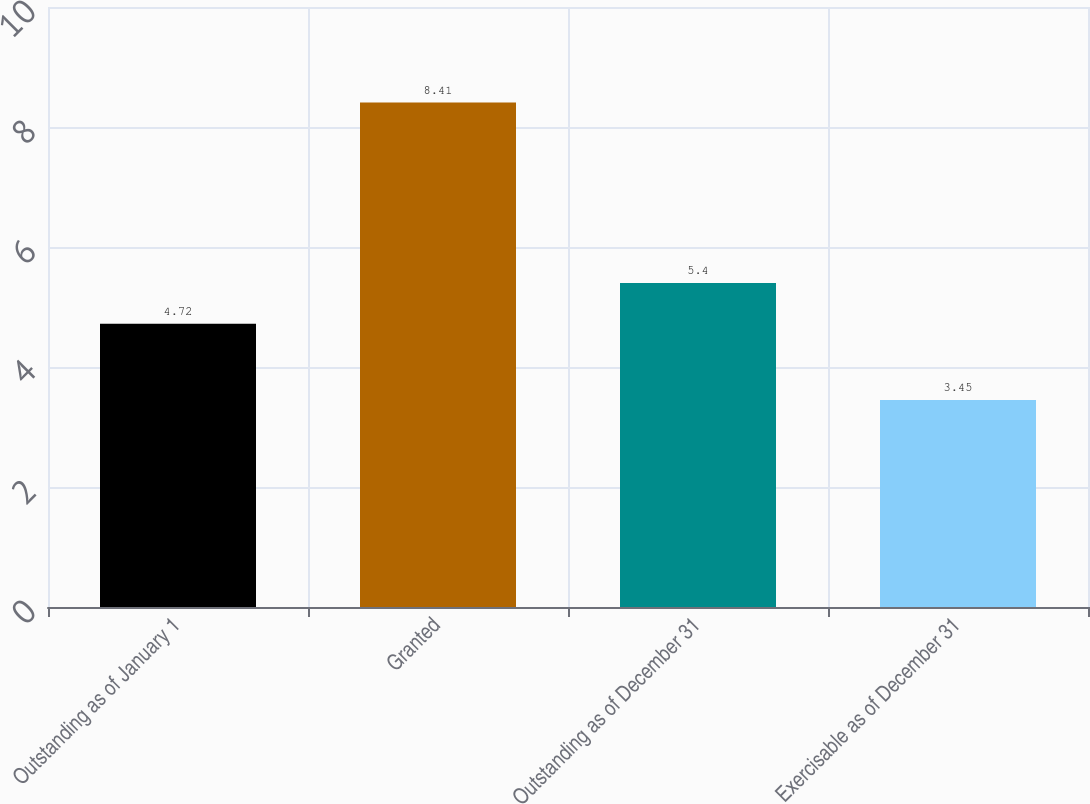<chart> <loc_0><loc_0><loc_500><loc_500><bar_chart><fcel>Outstanding as of January 1<fcel>Granted<fcel>Outstanding as of December 31<fcel>Exercisable as of December 31<nl><fcel>4.72<fcel>8.41<fcel>5.4<fcel>3.45<nl></chart> 